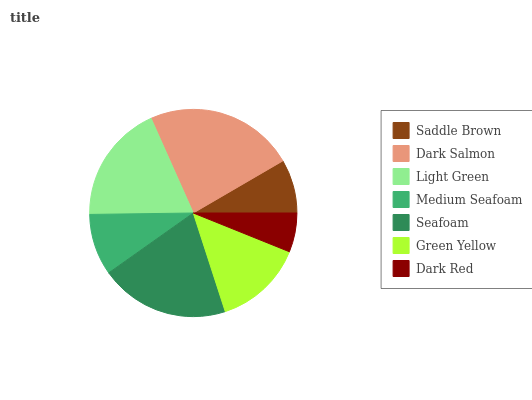Is Dark Red the minimum?
Answer yes or no. Yes. Is Dark Salmon the maximum?
Answer yes or no. Yes. Is Light Green the minimum?
Answer yes or no. No. Is Light Green the maximum?
Answer yes or no. No. Is Dark Salmon greater than Light Green?
Answer yes or no. Yes. Is Light Green less than Dark Salmon?
Answer yes or no. Yes. Is Light Green greater than Dark Salmon?
Answer yes or no. No. Is Dark Salmon less than Light Green?
Answer yes or no. No. Is Green Yellow the high median?
Answer yes or no. Yes. Is Green Yellow the low median?
Answer yes or no. Yes. Is Light Green the high median?
Answer yes or no. No. Is Dark Salmon the low median?
Answer yes or no. No. 